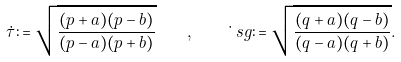Convert formula to latex. <formula><loc_0><loc_0><loc_500><loc_500>\dot { \tau } \colon = \sqrt { \frac { ( p + a ) ( p - b ) } { ( p - a ) ( p + b ) } } \quad , \quad \dot { \ } s g \colon = \sqrt { \frac { ( q + a ) ( q - b ) } { ( q - a ) ( q + b ) } } .</formula> 